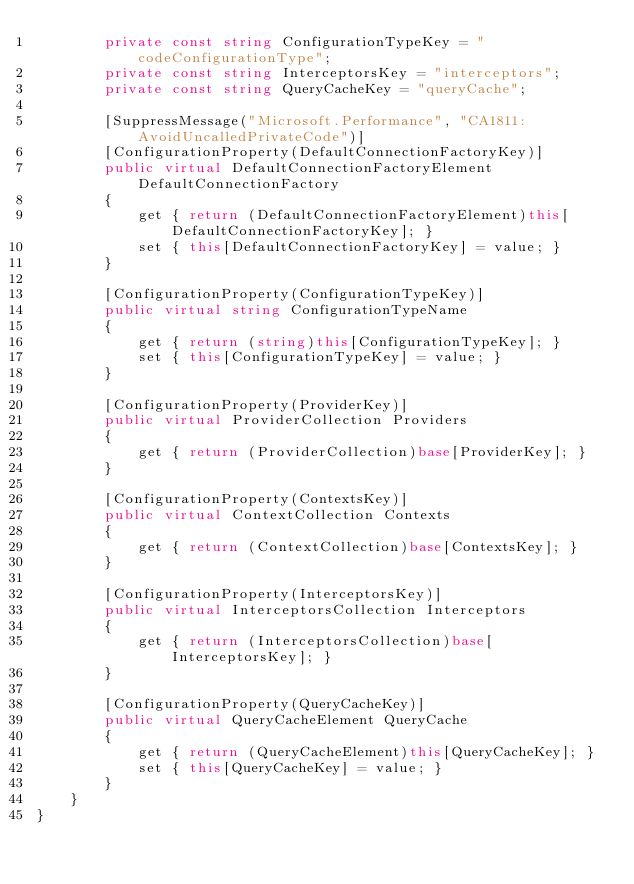<code> <loc_0><loc_0><loc_500><loc_500><_C#_>        private const string ConfigurationTypeKey = "codeConfigurationType";
        private const string InterceptorsKey = "interceptors";
        private const string QueryCacheKey = "queryCache";

        [SuppressMessage("Microsoft.Performance", "CA1811:AvoidUncalledPrivateCode")]
        [ConfigurationProperty(DefaultConnectionFactoryKey)]
        public virtual DefaultConnectionFactoryElement DefaultConnectionFactory
        {
            get { return (DefaultConnectionFactoryElement)this[DefaultConnectionFactoryKey]; }
            set { this[DefaultConnectionFactoryKey] = value; }
        }

        [ConfigurationProperty(ConfigurationTypeKey)]
        public virtual string ConfigurationTypeName
        {
            get { return (string)this[ConfigurationTypeKey]; }
            set { this[ConfigurationTypeKey] = value; }
        }

        [ConfigurationProperty(ProviderKey)]
        public virtual ProviderCollection Providers
        {
            get { return (ProviderCollection)base[ProviderKey]; }
        }

        [ConfigurationProperty(ContextsKey)]
        public virtual ContextCollection Contexts
        {
            get { return (ContextCollection)base[ContextsKey]; }
        }

        [ConfigurationProperty(InterceptorsKey)]
        public virtual InterceptorsCollection Interceptors
        {
            get { return (InterceptorsCollection)base[InterceptorsKey]; }
        }

        [ConfigurationProperty(QueryCacheKey)]
        public virtual QueryCacheElement QueryCache
        {
            get { return (QueryCacheElement)this[QueryCacheKey]; }
            set { this[QueryCacheKey] = value; }
        }
    }
}
</code> 